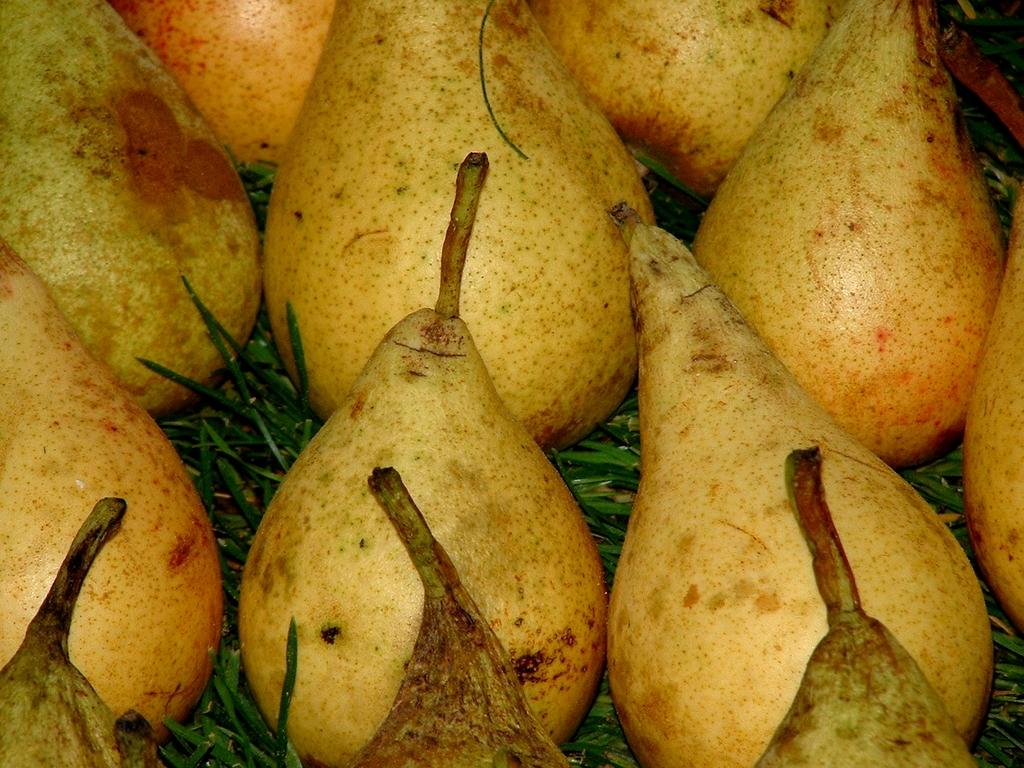What type of fruit is present in the image? There are pears in the image. How are the pears arranged in the image? The pears are arranged in a bunch. Where are the pears located in the image? The pears are on a grass path. What type of arch can be seen in the background of the image? There is no arch present in the image; it only features pears arranged in a bunch on a grass path. 